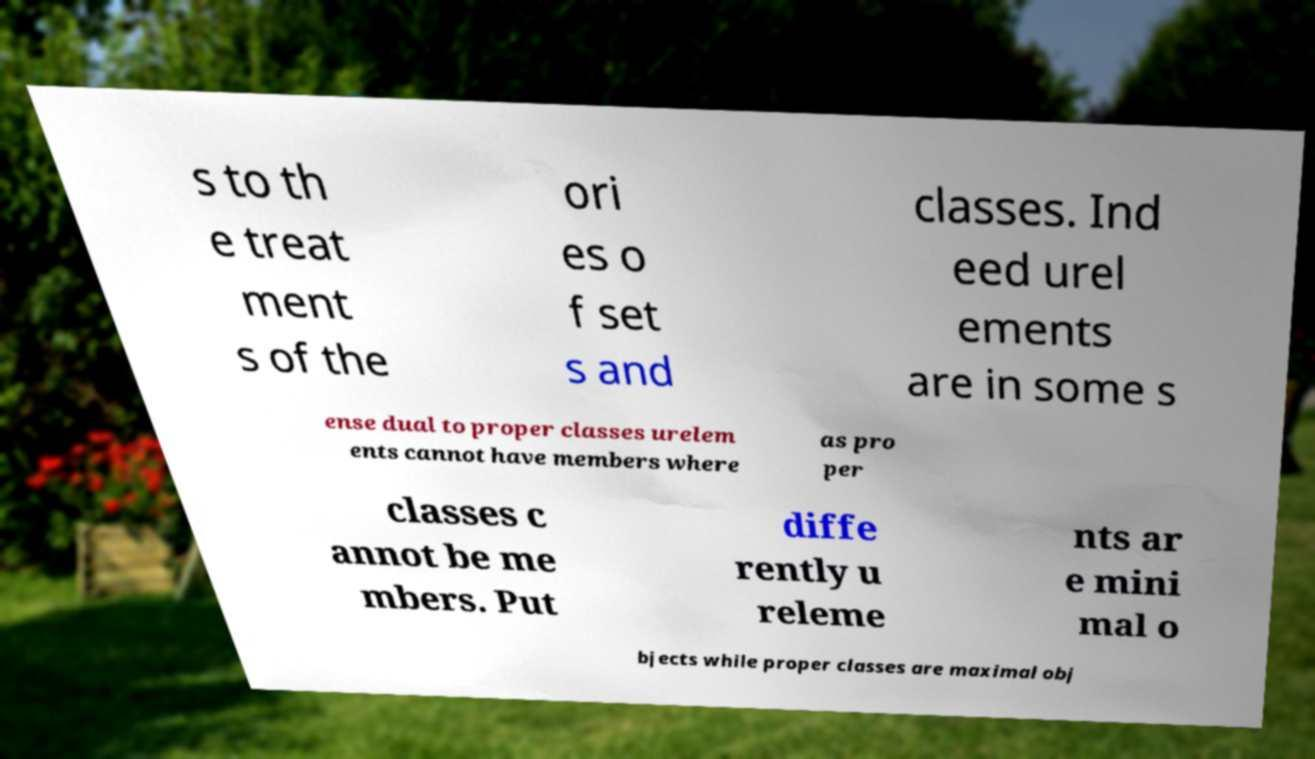Please read and relay the text visible in this image. What does it say? s to th e treat ment s of the ori es o f set s and classes. Ind eed urel ements are in some s ense dual to proper classes urelem ents cannot have members where as pro per classes c annot be me mbers. Put diffe rently u releme nts ar e mini mal o bjects while proper classes are maximal obj 